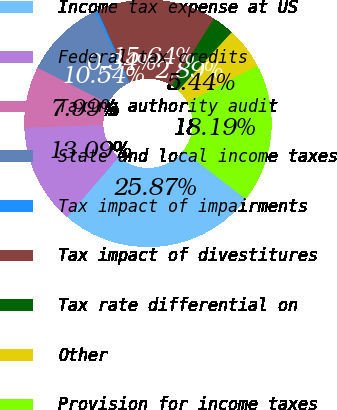Convert chart. <chart><loc_0><loc_0><loc_500><loc_500><pie_chart><fcel>Income tax expense at US<fcel>Federal tax credits<fcel>Taxing authority audit<fcel>State and local income taxes<fcel>Tax impact of impairments<fcel>Tax impact of divestitures<fcel>Tax rate differential on<fcel>Other<fcel>Provision for income taxes<nl><fcel>25.87%<fcel>13.09%<fcel>7.99%<fcel>10.54%<fcel>0.34%<fcel>15.64%<fcel>2.89%<fcel>5.44%<fcel>18.19%<nl></chart> 